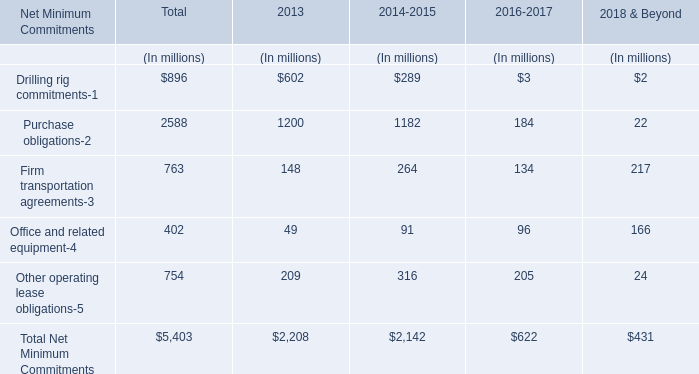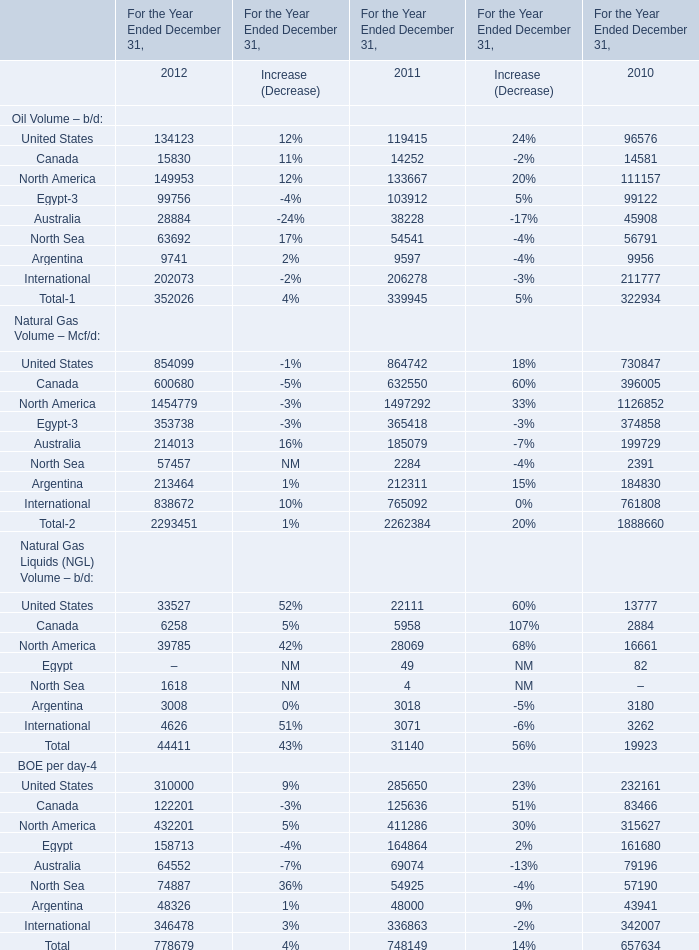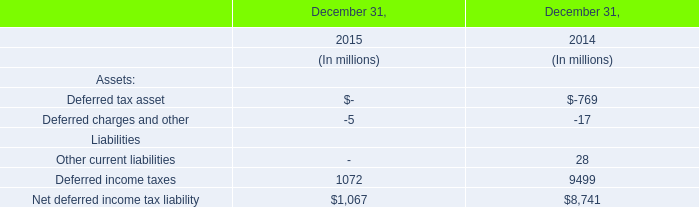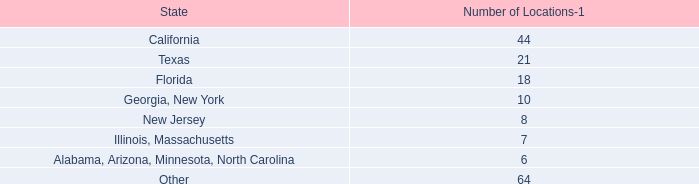What's the total amount of the oil volum in the years where North Sea is greater than 60000? 
Computations: ((((((134123 + 15830) + 149953) + 99756) + 28884) + 63692) + 9741)
Answer: 501979.0. 